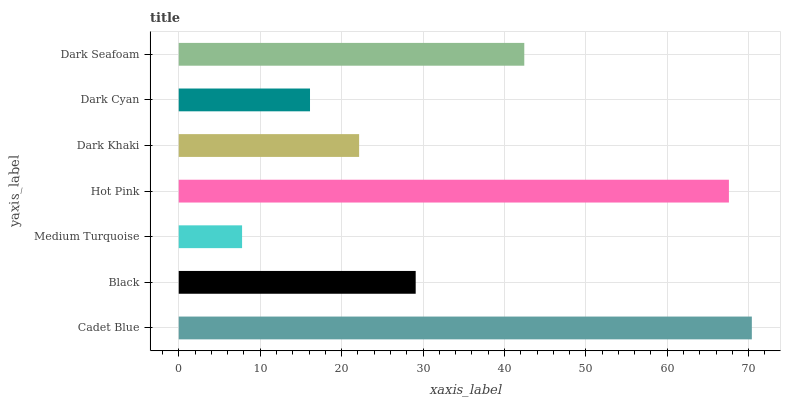Is Medium Turquoise the minimum?
Answer yes or no. Yes. Is Cadet Blue the maximum?
Answer yes or no. Yes. Is Black the minimum?
Answer yes or no. No. Is Black the maximum?
Answer yes or no. No. Is Cadet Blue greater than Black?
Answer yes or no. Yes. Is Black less than Cadet Blue?
Answer yes or no. Yes. Is Black greater than Cadet Blue?
Answer yes or no. No. Is Cadet Blue less than Black?
Answer yes or no. No. Is Black the high median?
Answer yes or no. Yes. Is Black the low median?
Answer yes or no. Yes. Is Dark Khaki the high median?
Answer yes or no. No. Is Dark Seafoam the low median?
Answer yes or no. No. 